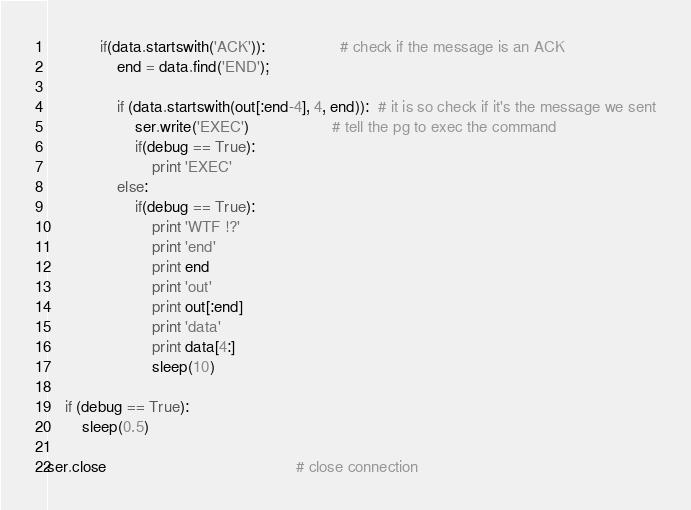Convert code to text. <code><loc_0><loc_0><loc_500><loc_500><_Python_>
            if(data.startswith('ACK')):                 # check if the message is an ACK
                end = data.find('END');

                if (data.startswith(out[:end-4], 4, end)):  # it is so check if it's the message we sent
                    ser.write('EXEC')                   # tell the pg to exec the command 
                    if(debug == True):  
                        print 'EXEC'
                else:
                    if(debug == True):
                        print 'WTF !?'
                        print 'end'
                        print end
                        print 'out'
                        print out[:end]
                        print 'data'
                        print data[4:]
                        sleep(10)

    if (debug == True):
        sleep(0.5)

ser.close                                           # close connection</code> 